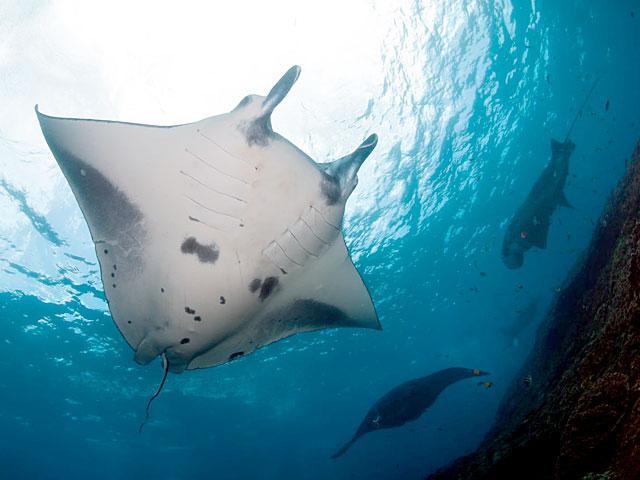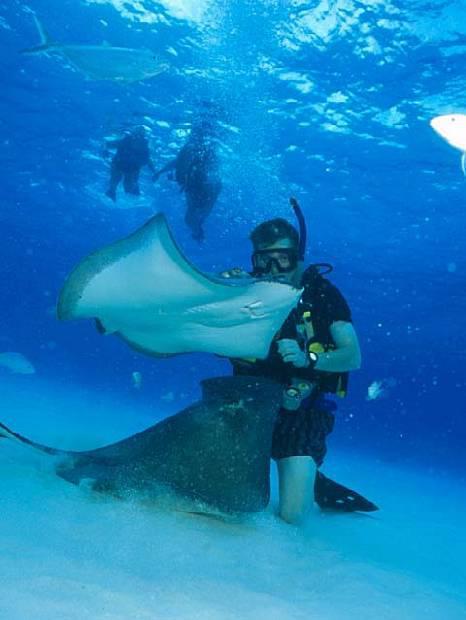The first image is the image on the left, the second image is the image on the right. Analyze the images presented: Is the assertion "There is a manta ray." valid? Answer yes or no. Yes. The first image is the image on the left, the second image is the image on the right. Evaluate the accuracy of this statement regarding the images: "There are at least two stingrays visible in the right image.". Is it true? Answer yes or no. Yes. 